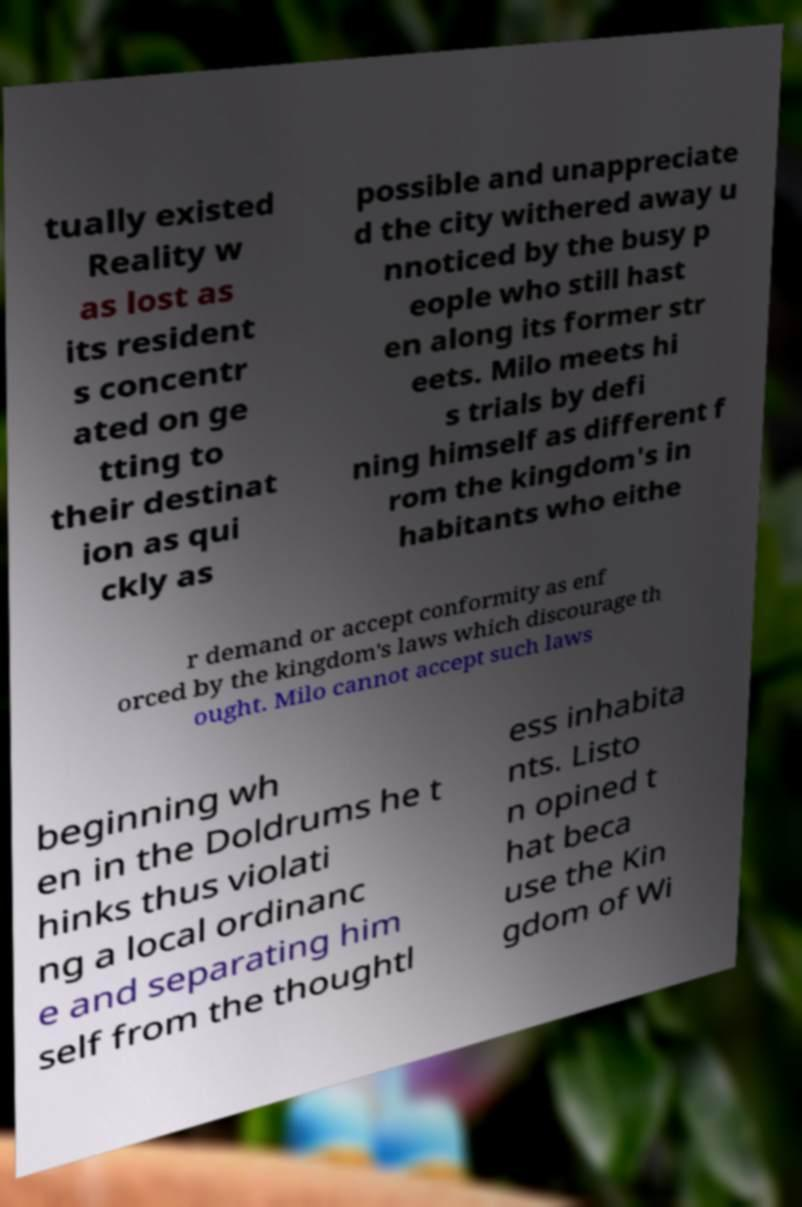Please read and relay the text visible in this image. What does it say? tually existed Reality w as lost as its resident s concentr ated on ge tting to their destinat ion as qui ckly as possible and unappreciate d the city withered away u nnoticed by the busy p eople who still hast en along its former str eets. Milo meets hi s trials by defi ning himself as different f rom the kingdom's in habitants who eithe r demand or accept conformity as enf orced by the kingdom's laws which discourage th ought. Milo cannot accept such laws beginning wh en in the Doldrums he t hinks thus violati ng a local ordinanc e and separating him self from the thoughtl ess inhabita nts. Listo n opined t hat beca use the Kin gdom of Wi 